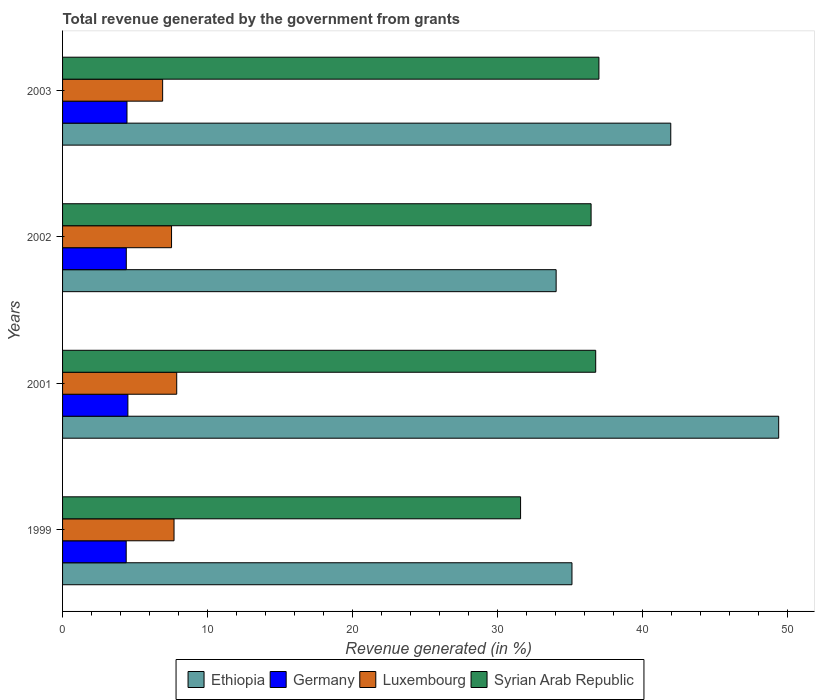How many different coloured bars are there?
Offer a very short reply. 4. Are the number of bars on each tick of the Y-axis equal?
Offer a terse response. Yes. How many bars are there on the 1st tick from the bottom?
Make the answer very short. 4. What is the total revenue generated in Luxembourg in 1999?
Offer a very short reply. 7.69. Across all years, what is the maximum total revenue generated in Syrian Arab Republic?
Give a very brief answer. 37. Across all years, what is the minimum total revenue generated in Germany?
Offer a very short reply. 4.39. In which year was the total revenue generated in Syrian Arab Republic maximum?
Make the answer very short. 2003. In which year was the total revenue generated in Luxembourg minimum?
Provide a succinct answer. 2003. What is the total total revenue generated in Syrian Arab Republic in the graph?
Provide a succinct answer. 141.84. What is the difference between the total revenue generated in Ethiopia in 1999 and that in 2002?
Offer a terse response. 1.09. What is the difference between the total revenue generated in Ethiopia in 2001 and the total revenue generated in Luxembourg in 1999?
Offer a very short reply. 41.71. What is the average total revenue generated in Ethiopia per year?
Your answer should be very brief. 40.14. In the year 2003, what is the difference between the total revenue generated in Luxembourg and total revenue generated in Germany?
Make the answer very short. 2.46. In how many years, is the total revenue generated in Luxembourg greater than 22 %?
Provide a succinct answer. 0. What is the ratio of the total revenue generated in Ethiopia in 1999 to that in 2001?
Keep it short and to the point. 0.71. Is the difference between the total revenue generated in Luxembourg in 1999 and 2002 greater than the difference between the total revenue generated in Germany in 1999 and 2002?
Make the answer very short. Yes. What is the difference between the highest and the second highest total revenue generated in Luxembourg?
Provide a succinct answer. 0.18. What is the difference between the highest and the lowest total revenue generated in Syrian Arab Republic?
Ensure brevity in your answer.  5.4. In how many years, is the total revenue generated in Luxembourg greater than the average total revenue generated in Luxembourg taken over all years?
Provide a short and direct response. 3. What does the 4th bar from the top in 2001 represents?
Offer a terse response. Ethiopia. What does the 4th bar from the bottom in 2002 represents?
Provide a short and direct response. Syrian Arab Republic. Is it the case that in every year, the sum of the total revenue generated in Germany and total revenue generated in Luxembourg is greater than the total revenue generated in Syrian Arab Republic?
Provide a short and direct response. No. How many bars are there?
Offer a very short reply. 16. What is the difference between two consecutive major ticks on the X-axis?
Your response must be concise. 10. Are the values on the major ticks of X-axis written in scientific E-notation?
Your response must be concise. No. Does the graph contain any zero values?
Offer a terse response. No. Does the graph contain grids?
Provide a succinct answer. No. Where does the legend appear in the graph?
Offer a very short reply. Bottom center. What is the title of the graph?
Provide a succinct answer. Total revenue generated by the government from grants. Does "East Asia (developing only)" appear as one of the legend labels in the graph?
Offer a very short reply. No. What is the label or title of the X-axis?
Keep it short and to the point. Revenue generated (in %). What is the label or title of the Y-axis?
Give a very brief answer. Years. What is the Revenue generated (in %) of Ethiopia in 1999?
Give a very brief answer. 35.14. What is the Revenue generated (in %) of Germany in 1999?
Offer a very short reply. 4.39. What is the Revenue generated (in %) of Luxembourg in 1999?
Make the answer very short. 7.69. What is the Revenue generated (in %) in Syrian Arab Republic in 1999?
Your response must be concise. 31.6. What is the Revenue generated (in %) in Ethiopia in 2001?
Make the answer very short. 49.4. What is the Revenue generated (in %) of Germany in 2001?
Offer a very short reply. 4.51. What is the Revenue generated (in %) in Luxembourg in 2001?
Offer a terse response. 7.87. What is the Revenue generated (in %) of Syrian Arab Republic in 2001?
Give a very brief answer. 36.78. What is the Revenue generated (in %) in Ethiopia in 2002?
Your answer should be very brief. 34.05. What is the Revenue generated (in %) in Germany in 2002?
Provide a succinct answer. 4.4. What is the Revenue generated (in %) of Luxembourg in 2002?
Offer a very short reply. 7.52. What is the Revenue generated (in %) of Syrian Arab Republic in 2002?
Keep it short and to the point. 36.46. What is the Revenue generated (in %) of Ethiopia in 2003?
Keep it short and to the point. 41.96. What is the Revenue generated (in %) of Germany in 2003?
Offer a terse response. 4.44. What is the Revenue generated (in %) of Luxembourg in 2003?
Provide a short and direct response. 6.9. What is the Revenue generated (in %) of Syrian Arab Republic in 2003?
Ensure brevity in your answer.  37. Across all years, what is the maximum Revenue generated (in %) in Ethiopia?
Provide a succinct answer. 49.4. Across all years, what is the maximum Revenue generated (in %) in Germany?
Your answer should be very brief. 4.51. Across all years, what is the maximum Revenue generated (in %) in Luxembourg?
Provide a succinct answer. 7.87. Across all years, what is the maximum Revenue generated (in %) of Syrian Arab Republic?
Your answer should be very brief. 37. Across all years, what is the minimum Revenue generated (in %) in Ethiopia?
Make the answer very short. 34.05. Across all years, what is the minimum Revenue generated (in %) in Germany?
Your response must be concise. 4.39. Across all years, what is the minimum Revenue generated (in %) in Luxembourg?
Offer a very short reply. 6.9. Across all years, what is the minimum Revenue generated (in %) in Syrian Arab Republic?
Offer a terse response. 31.6. What is the total Revenue generated (in %) in Ethiopia in the graph?
Your answer should be very brief. 160.55. What is the total Revenue generated (in %) of Germany in the graph?
Make the answer very short. 17.74. What is the total Revenue generated (in %) of Luxembourg in the graph?
Give a very brief answer. 29.99. What is the total Revenue generated (in %) in Syrian Arab Republic in the graph?
Your answer should be very brief. 141.84. What is the difference between the Revenue generated (in %) in Ethiopia in 1999 and that in 2001?
Give a very brief answer. -14.26. What is the difference between the Revenue generated (in %) in Germany in 1999 and that in 2001?
Offer a very short reply. -0.12. What is the difference between the Revenue generated (in %) of Luxembourg in 1999 and that in 2001?
Provide a succinct answer. -0.18. What is the difference between the Revenue generated (in %) of Syrian Arab Republic in 1999 and that in 2001?
Keep it short and to the point. -5.18. What is the difference between the Revenue generated (in %) of Ethiopia in 1999 and that in 2002?
Keep it short and to the point. 1.09. What is the difference between the Revenue generated (in %) in Germany in 1999 and that in 2002?
Offer a terse response. -0.01. What is the difference between the Revenue generated (in %) of Luxembourg in 1999 and that in 2002?
Your answer should be compact. 0.17. What is the difference between the Revenue generated (in %) of Syrian Arab Republic in 1999 and that in 2002?
Make the answer very short. -4.86. What is the difference between the Revenue generated (in %) of Ethiopia in 1999 and that in 2003?
Offer a very short reply. -6.81. What is the difference between the Revenue generated (in %) in Germany in 1999 and that in 2003?
Your answer should be compact. -0.05. What is the difference between the Revenue generated (in %) in Luxembourg in 1999 and that in 2003?
Your answer should be very brief. 0.79. What is the difference between the Revenue generated (in %) in Syrian Arab Republic in 1999 and that in 2003?
Keep it short and to the point. -5.4. What is the difference between the Revenue generated (in %) in Ethiopia in 2001 and that in 2002?
Offer a terse response. 15.35. What is the difference between the Revenue generated (in %) of Germany in 2001 and that in 2002?
Provide a short and direct response. 0.11. What is the difference between the Revenue generated (in %) in Luxembourg in 2001 and that in 2002?
Keep it short and to the point. 0.36. What is the difference between the Revenue generated (in %) of Syrian Arab Republic in 2001 and that in 2002?
Your answer should be very brief. 0.32. What is the difference between the Revenue generated (in %) in Ethiopia in 2001 and that in 2003?
Ensure brevity in your answer.  7.45. What is the difference between the Revenue generated (in %) in Germany in 2001 and that in 2003?
Your answer should be very brief. 0.06. What is the difference between the Revenue generated (in %) in Luxembourg in 2001 and that in 2003?
Your answer should be very brief. 0.97. What is the difference between the Revenue generated (in %) in Syrian Arab Republic in 2001 and that in 2003?
Provide a short and direct response. -0.22. What is the difference between the Revenue generated (in %) in Ethiopia in 2002 and that in 2003?
Offer a terse response. -7.91. What is the difference between the Revenue generated (in %) of Germany in 2002 and that in 2003?
Offer a very short reply. -0.05. What is the difference between the Revenue generated (in %) of Luxembourg in 2002 and that in 2003?
Your response must be concise. 0.61. What is the difference between the Revenue generated (in %) of Syrian Arab Republic in 2002 and that in 2003?
Give a very brief answer. -0.54. What is the difference between the Revenue generated (in %) of Ethiopia in 1999 and the Revenue generated (in %) of Germany in 2001?
Your answer should be compact. 30.64. What is the difference between the Revenue generated (in %) in Ethiopia in 1999 and the Revenue generated (in %) in Luxembourg in 2001?
Make the answer very short. 27.27. What is the difference between the Revenue generated (in %) in Ethiopia in 1999 and the Revenue generated (in %) in Syrian Arab Republic in 2001?
Provide a short and direct response. -1.64. What is the difference between the Revenue generated (in %) of Germany in 1999 and the Revenue generated (in %) of Luxembourg in 2001?
Offer a terse response. -3.48. What is the difference between the Revenue generated (in %) of Germany in 1999 and the Revenue generated (in %) of Syrian Arab Republic in 2001?
Offer a very short reply. -32.39. What is the difference between the Revenue generated (in %) of Luxembourg in 1999 and the Revenue generated (in %) of Syrian Arab Republic in 2001?
Your response must be concise. -29.09. What is the difference between the Revenue generated (in %) in Ethiopia in 1999 and the Revenue generated (in %) in Germany in 2002?
Offer a terse response. 30.74. What is the difference between the Revenue generated (in %) of Ethiopia in 1999 and the Revenue generated (in %) of Luxembourg in 2002?
Offer a terse response. 27.62. What is the difference between the Revenue generated (in %) in Ethiopia in 1999 and the Revenue generated (in %) in Syrian Arab Republic in 2002?
Make the answer very short. -1.32. What is the difference between the Revenue generated (in %) in Germany in 1999 and the Revenue generated (in %) in Luxembourg in 2002?
Make the answer very short. -3.13. What is the difference between the Revenue generated (in %) in Germany in 1999 and the Revenue generated (in %) in Syrian Arab Republic in 2002?
Your answer should be very brief. -32.07. What is the difference between the Revenue generated (in %) of Luxembourg in 1999 and the Revenue generated (in %) of Syrian Arab Republic in 2002?
Offer a very short reply. -28.77. What is the difference between the Revenue generated (in %) in Ethiopia in 1999 and the Revenue generated (in %) in Germany in 2003?
Your answer should be compact. 30.7. What is the difference between the Revenue generated (in %) in Ethiopia in 1999 and the Revenue generated (in %) in Luxembourg in 2003?
Give a very brief answer. 28.24. What is the difference between the Revenue generated (in %) in Ethiopia in 1999 and the Revenue generated (in %) in Syrian Arab Republic in 2003?
Provide a short and direct response. -1.86. What is the difference between the Revenue generated (in %) of Germany in 1999 and the Revenue generated (in %) of Luxembourg in 2003?
Your answer should be very brief. -2.51. What is the difference between the Revenue generated (in %) of Germany in 1999 and the Revenue generated (in %) of Syrian Arab Republic in 2003?
Offer a very short reply. -32.61. What is the difference between the Revenue generated (in %) of Luxembourg in 1999 and the Revenue generated (in %) of Syrian Arab Republic in 2003?
Provide a succinct answer. -29.31. What is the difference between the Revenue generated (in %) in Ethiopia in 2001 and the Revenue generated (in %) in Germany in 2002?
Provide a succinct answer. 45. What is the difference between the Revenue generated (in %) of Ethiopia in 2001 and the Revenue generated (in %) of Luxembourg in 2002?
Ensure brevity in your answer.  41.88. What is the difference between the Revenue generated (in %) in Ethiopia in 2001 and the Revenue generated (in %) in Syrian Arab Republic in 2002?
Make the answer very short. 12.94. What is the difference between the Revenue generated (in %) in Germany in 2001 and the Revenue generated (in %) in Luxembourg in 2002?
Make the answer very short. -3.01. What is the difference between the Revenue generated (in %) of Germany in 2001 and the Revenue generated (in %) of Syrian Arab Republic in 2002?
Your answer should be compact. -31.95. What is the difference between the Revenue generated (in %) of Luxembourg in 2001 and the Revenue generated (in %) of Syrian Arab Republic in 2002?
Your answer should be very brief. -28.59. What is the difference between the Revenue generated (in %) in Ethiopia in 2001 and the Revenue generated (in %) in Germany in 2003?
Your answer should be compact. 44.96. What is the difference between the Revenue generated (in %) in Ethiopia in 2001 and the Revenue generated (in %) in Luxembourg in 2003?
Your response must be concise. 42.5. What is the difference between the Revenue generated (in %) in Ethiopia in 2001 and the Revenue generated (in %) in Syrian Arab Republic in 2003?
Offer a very short reply. 12.4. What is the difference between the Revenue generated (in %) in Germany in 2001 and the Revenue generated (in %) in Luxembourg in 2003?
Offer a very short reply. -2.4. What is the difference between the Revenue generated (in %) of Germany in 2001 and the Revenue generated (in %) of Syrian Arab Republic in 2003?
Your answer should be very brief. -32.49. What is the difference between the Revenue generated (in %) of Luxembourg in 2001 and the Revenue generated (in %) of Syrian Arab Republic in 2003?
Offer a terse response. -29.13. What is the difference between the Revenue generated (in %) of Ethiopia in 2002 and the Revenue generated (in %) of Germany in 2003?
Provide a short and direct response. 29.6. What is the difference between the Revenue generated (in %) of Ethiopia in 2002 and the Revenue generated (in %) of Luxembourg in 2003?
Offer a terse response. 27.14. What is the difference between the Revenue generated (in %) in Ethiopia in 2002 and the Revenue generated (in %) in Syrian Arab Republic in 2003?
Provide a succinct answer. -2.95. What is the difference between the Revenue generated (in %) in Germany in 2002 and the Revenue generated (in %) in Luxembourg in 2003?
Your answer should be very brief. -2.51. What is the difference between the Revenue generated (in %) of Germany in 2002 and the Revenue generated (in %) of Syrian Arab Republic in 2003?
Give a very brief answer. -32.6. What is the difference between the Revenue generated (in %) in Luxembourg in 2002 and the Revenue generated (in %) in Syrian Arab Republic in 2003?
Provide a short and direct response. -29.48. What is the average Revenue generated (in %) in Ethiopia per year?
Ensure brevity in your answer.  40.14. What is the average Revenue generated (in %) in Germany per year?
Offer a terse response. 4.43. What is the average Revenue generated (in %) in Luxembourg per year?
Provide a short and direct response. 7.5. What is the average Revenue generated (in %) of Syrian Arab Republic per year?
Keep it short and to the point. 35.46. In the year 1999, what is the difference between the Revenue generated (in %) of Ethiopia and Revenue generated (in %) of Germany?
Make the answer very short. 30.75. In the year 1999, what is the difference between the Revenue generated (in %) in Ethiopia and Revenue generated (in %) in Luxembourg?
Ensure brevity in your answer.  27.45. In the year 1999, what is the difference between the Revenue generated (in %) in Ethiopia and Revenue generated (in %) in Syrian Arab Republic?
Your answer should be compact. 3.55. In the year 1999, what is the difference between the Revenue generated (in %) in Germany and Revenue generated (in %) in Luxembourg?
Provide a short and direct response. -3.3. In the year 1999, what is the difference between the Revenue generated (in %) in Germany and Revenue generated (in %) in Syrian Arab Republic?
Keep it short and to the point. -27.21. In the year 1999, what is the difference between the Revenue generated (in %) in Luxembourg and Revenue generated (in %) in Syrian Arab Republic?
Offer a terse response. -23.91. In the year 2001, what is the difference between the Revenue generated (in %) in Ethiopia and Revenue generated (in %) in Germany?
Make the answer very short. 44.9. In the year 2001, what is the difference between the Revenue generated (in %) of Ethiopia and Revenue generated (in %) of Luxembourg?
Your answer should be very brief. 41.53. In the year 2001, what is the difference between the Revenue generated (in %) in Ethiopia and Revenue generated (in %) in Syrian Arab Republic?
Keep it short and to the point. 12.62. In the year 2001, what is the difference between the Revenue generated (in %) in Germany and Revenue generated (in %) in Luxembourg?
Your response must be concise. -3.37. In the year 2001, what is the difference between the Revenue generated (in %) of Germany and Revenue generated (in %) of Syrian Arab Republic?
Ensure brevity in your answer.  -32.27. In the year 2001, what is the difference between the Revenue generated (in %) of Luxembourg and Revenue generated (in %) of Syrian Arab Republic?
Provide a short and direct response. -28.9. In the year 2002, what is the difference between the Revenue generated (in %) of Ethiopia and Revenue generated (in %) of Germany?
Keep it short and to the point. 29.65. In the year 2002, what is the difference between the Revenue generated (in %) in Ethiopia and Revenue generated (in %) in Luxembourg?
Ensure brevity in your answer.  26.53. In the year 2002, what is the difference between the Revenue generated (in %) of Ethiopia and Revenue generated (in %) of Syrian Arab Republic?
Your response must be concise. -2.41. In the year 2002, what is the difference between the Revenue generated (in %) in Germany and Revenue generated (in %) in Luxembourg?
Provide a short and direct response. -3.12. In the year 2002, what is the difference between the Revenue generated (in %) of Germany and Revenue generated (in %) of Syrian Arab Republic?
Offer a very short reply. -32.06. In the year 2002, what is the difference between the Revenue generated (in %) in Luxembourg and Revenue generated (in %) in Syrian Arab Republic?
Provide a succinct answer. -28.94. In the year 2003, what is the difference between the Revenue generated (in %) of Ethiopia and Revenue generated (in %) of Germany?
Make the answer very short. 37.51. In the year 2003, what is the difference between the Revenue generated (in %) of Ethiopia and Revenue generated (in %) of Luxembourg?
Give a very brief answer. 35.05. In the year 2003, what is the difference between the Revenue generated (in %) in Ethiopia and Revenue generated (in %) in Syrian Arab Republic?
Ensure brevity in your answer.  4.96. In the year 2003, what is the difference between the Revenue generated (in %) of Germany and Revenue generated (in %) of Luxembourg?
Keep it short and to the point. -2.46. In the year 2003, what is the difference between the Revenue generated (in %) in Germany and Revenue generated (in %) in Syrian Arab Republic?
Your response must be concise. -32.56. In the year 2003, what is the difference between the Revenue generated (in %) in Luxembourg and Revenue generated (in %) in Syrian Arab Republic?
Offer a terse response. -30.1. What is the ratio of the Revenue generated (in %) of Ethiopia in 1999 to that in 2001?
Your answer should be very brief. 0.71. What is the ratio of the Revenue generated (in %) in Germany in 1999 to that in 2001?
Keep it short and to the point. 0.97. What is the ratio of the Revenue generated (in %) of Luxembourg in 1999 to that in 2001?
Your answer should be very brief. 0.98. What is the ratio of the Revenue generated (in %) in Syrian Arab Republic in 1999 to that in 2001?
Make the answer very short. 0.86. What is the ratio of the Revenue generated (in %) in Ethiopia in 1999 to that in 2002?
Ensure brevity in your answer.  1.03. What is the ratio of the Revenue generated (in %) in Luxembourg in 1999 to that in 2002?
Provide a succinct answer. 1.02. What is the ratio of the Revenue generated (in %) of Syrian Arab Republic in 1999 to that in 2002?
Provide a succinct answer. 0.87. What is the ratio of the Revenue generated (in %) in Ethiopia in 1999 to that in 2003?
Provide a succinct answer. 0.84. What is the ratio of the Revenue generated (in %) of Luxembourg in 1999 to that in 2003?
Offer a terse response. 1.11. What is the ratio of the Revenue generated (in %) of Syrian Arab Republic in 1999 to that in 2003?
Provide a succinct answer. 0.85. What is the ratio of the Revenue generated (in %) of Ethiopia in 2001 to that in 2002?
Give a very brief answer. 1.45. What is the ratio of the Revenue generated (in %) in Germany in 2001 to that in 2002?
Your answer should be compact. 1.02. What is the ratio of the Revenue generated (in %) of Luxembourg in 2001 to that in 2002?
Offer a very short reply. 1.05. What is the ratio of the Revenue generated (in %) in Syrian Arab Republic in 2001 to that in 2002?
Your response must be concise. 1.01. What is the ratio of the Revenue generated (in %) of Ethiopia in 2001 to that in 2003?
Give a very brief answer. 1.18. What is the ratio of the Revenue generated (in %) in Luxembourg in 2001 to that in 2003?
Make the answer very short. 1.14. What is the ratio of the Revenue generated (in %) of Ethiopia in 2002 to that in 2003?
Provide a short and direct response. 0.81. What is the ratio of the Revenue generated (in %) in Luxembourg in 2002 to that in 2003?
Give a very brief answer. 1.09. What is the ratio of the Revenue generated (in %) of Syrian Arab Republic in 2002 to that in 2003?
Make the answer very short. 0.99. What is the difference between the highest and the second highest Revenue generated (in %) of Ethiopia?
Provide a succinct answer. 7.45. What is the difference between the highest and the second highest Revenue generated (in %) of Germany?
Give a very brief answer. 0.06. What is the difference between the highest and the second highest Revenue generated (in %) of Luxembourg?
Provide a succinct answer. 0.18. What is the difference between the highest and the second highest Revenue generated (in %) in Syrian Arab Republic?
Ensure brevity in your answer.  0.22. What is the difference between the highest and the lowest Revenue generated (in %) in Ethiopia?
Keep it short and to the point. 15.35. What is the difference between the highest and the lowest Revenue generated (in %) in Germany?
Provide a short and direct response. 0.12. What is the difference between the highest and the lowest Revenue generated (in %) in Luxembourg?
Offer a very short reply. 0.97. What is the difference between the highest and the lowest Revenue generated (in %) in Syrian Arab Republic?
Your answer should be very brief. 5.4. 